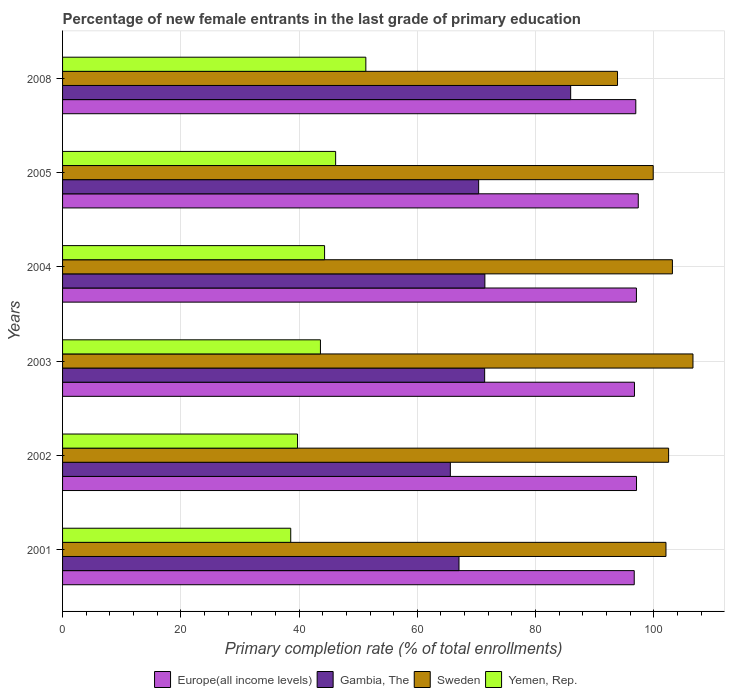How many groups of bars are there?
Your answer should be very brief. 6. How many bars are there on the 5th tick from the top?
Keep it short and to the point. 4. How many bars are there on the 2nd tick from the bottom?
Ensure brevity in your answer.  4. In how many cases, is the number of bars for a given year not equal to the number of legend labels?
Your answer should be compact. 0. What is the percentage of new female entrants in Gambia, The in 2001?
Your answer should be very brief. 67.05. Across all years, what is the maximum percentage of new female entrants in Europe(all income levels)?
Provide a short and direct response. 97.37. Across all years, what is the minimum percentage of new female entrants in Sweden?
Your response must be concise. 93.86. In which year was the percentage of new female entrants in Gambia, The maximum?
Your answer should be very brief. 2008. What is the total percentage of new female entrants in Yemen, Rep. in the graph?
Your answer should be compact. 263.76. What is the difference between the percentage of new female entrants in Sweden in 2004 and that in 2005?
Your response must be concise. 3.25. What is the difference between the percentage of new female entrants in Yemen, Rep. in 2008 and the percentage of new female entrants in Europe(all income levels) in 2003?
Ensure brevity in your answer.  -45.44. What is the average percentage of new female entrants in Europe(all income levels) per year?
Provide a succinct answer. 96.98. In the year 2005, what is the difference between the percentage of new female entrants in Sweden and percentage of new female entrants in Yemen, Rep.?
Provide a short and direct response. 53.71. In how many years, is the percentage of new female entrants in Gambia, The greater than 44 %?
Provide a succinct answer. 6. What is the ratio of the percentage of new female entrants in Gambia, The in 2001 to that in 2002?
Make the answer very short. 1.02. Is the percentage of new female entrants in Sweden in 2001 less than that in 2004?
Offer a very short reply. Yes. What is the difference between the highest and the second highest percentage of new female entrants in Gambia, The?
Keep it short and to the point. 14.51. What is the difference between the highest and the lowest percentage of new female entrants in Europe(all income levels)?
Ensure brevity in your answer.  0.68. What does the 4th bar from the top in 2004 represents?
Your answer should be very brief. Europe(all income levels). What does the 1st bar from the bottom in 2003 represents?
Your response must be concise. Europe(all income levels). What is the difference between two consecutive major ticks on the X-axis?
Offer a very short reply. 20. Are the values on the major ticks of X-axis written in scientific E-notation?
Keep it short and to the point. No. Does the graph contain grids?
Offer a very short reply. Yes. How many legend labels are there?
Ensure brevity in your answer.  4. How are the legend labels stacked?
Offer a very short reply. Horizontal. What is the title of the graph?
Your answer should be compact. Percentage of new female entrants in the last grade of primary education. What is the label or title of the X-axis?
Your response must be concise. Primary completion rate (% of total enrollments). What is the label or title of the Y-axis?
Offer a very short reply. Years. What is the Primary completion rate (% of total enrollments) in Europe(all income levels) in 2001?
Your answer should be very brief. 96.69. What is the Primary completion rate (% of total enrollments) of Gambia, The in 2001?
Your response must be concise. 67.05. What is the Primary completion rate (% of total enrollments) of Sweden in 2001?
Offer a terse response. 102.06. What is the Primary completion rate (% of total enrollments) in Yemen, Rep. in 2001?
Provide a succinct answer. 38.59. What is the Primary completion rate (% of total enrollments) in Europe(all income levels) in 2002?
Your answer should be very brief. 97.08. What is the Primary completion rate (% of total enrollments) in Gambia, The in 2002?
Your answer should be very brief. 65.59. What is the Primary completion rate (% of total enrollments) of Sweden in 2002?
Provide a succinct answer. 102.51. What is the Primary completion rate (% of total enrollments) in Yemen, Rep. in 2002?
Offer a very short reply. 39.74. What is the Primary completion rate (% of total enrollments) of Europe(all income levels) in 2003?
Provide a short and direct response. 96.73. What is the Primary completion rate (% of total enrollments) in Gambia, The in 2003?
Provide a short and direct response. 71.39. What is the Primary completion rate (% of total enrollments) in Sweden in 2003?
Ensure brevity in your answer.  106.63. What is the Primary completion rate (% of total enrollments) in Yemen, Rep. in 2003?
Provide a short and direct response. 43.62. What is the Primary completion rate (% of total enrollments) in Europe(all income levels) in 2004?
Give a very brief answer. 97.06. What is the Primary completion rate (% of total enrollments) in Gambia, The in 2004?
Offer a terse response. 71.43. What is the Primary completion rate (% of total enrollments) in Sweden in 2004?
Your answer should be compact. 103.15. What is the Primary completion rate (% of total enrollments) of Yemen, Rep. in 2004?
Your response must be concise. 44.32. What is the Primary completion rate (% of total enrollments) in Europe(all income levels) in 2005?
Provide a succinct answer. 97.37. What is the Primary completion rate (% of total enrollments) in Gambia, The in 2005?
Make the answer very short. 70.38. What is the Primary completion rate (% of total enrollments) of Sweden in 2005?
Provide a succinct answer. 99.9. What is the Primary completion rate (% of total enrollments) in Yemen, Rep. in 2005?
Your answer should be very brief. 46.19. What is the Primary completion rate (% of total enrollments) of Europe(all income levels) in 2008?
Ensure brevity in your answer.  96.96. What is the Primary completion rate (% of total enrollments) in Gambia, The in 2008?
Offer a very short reply. 85.94. What is the Primary completion rate (% of total enrollments) of Sweden in 2008?
Offer a very short reply. 93.86. What is the Primary completion rate (% of total enrollments) of Yemen, Rep. in 2008?
Keep it short and to the point. 51.3. Across all years, what is the maximum Primary completion rate (% of total enrollments) in Europe(all income levels)?
Ensure brevity in your answer.  97.37. Across all years, what is the maximum Primary completion rate (% of total enrollments) of Gambia, The?
Make the answer very short. 85.94. Across all years, what is the maximum Primary completion rate (% of total enrollments) in Sweden?
Your answer should be very brief. 106.63. Across all years, what is the maximum Primary completion rate (% of total enrollments) of Yemen, Rep.?
Your response must be concise. 51.3. Across all years, what is the minimum Primary completion rate (% of total enrollments) of Europe(all income levels)?
Provide a succinct answer. 96.69. Across all years, what is the minimum Primary completion rate (% of total enrollments) in Gambia, The?
Offer a terse response. 65.59. Across all years, what is the minimum Primary completion rate (% of total enrollments) of Sweden?
Offer a terse response. 93.86. Across all years, what is the minimum Primary completion rate (% of total enrollments) in Yemen, Rep.?
Ensure brevity in your answer.  38.59. What is the total Primary completion rate (% of total enrollments) in Europe(all income levels) in the graph?
Offer a terse response. 581.9. What is the total Primary completion rate (% of total enrollments) in Gambia, The in the graph?
Make the answer very short. 431.78. What is the total Primary completion rate (% of total enrollments) in Sweden in the graph?
Give a very brief answer. 608.11. What is the total Primary completion rate (% of total enrollments) in Yemen, Rep. in the graph?
Provide a short and direct response. 263.76. What is the difference between the Primary completion rate (% of total enrollments) in Europe(all income levels) in 2001 and that in 2002?
Provide a succinct answer. -0.39. What is the difference between the Primary completion rate (% of total enrollments) of Gambia, The in 2001 and that in 2002?
Your response must be concise. 1.46. What is the difference between the Primary completion rate (% of total enrollments) of Sweden in 2001 and that in 2002?
Your answer should be compact. -0.45. What is the difference between the Primary completion rate (% of total enrollments) in Yemen, Rep. in 2001 and that in 2002?
Your response must be concise. -1.15. What is the difference between the Primary completion rate (% of total enrollments) of Europe(all income levels) in 2001 and that in 2003?
Provide a short and direct response. -0.04. What is the difference between the Primary completion rate (% of total enrollments) in Gambia, The in 2001 and that in 2003?
Provide a short and direct response. -4.34. What is the difference between the Primary completion rate (% of total enrollments) of Sweden in 2001 and that in 2003?
Offer a terse response. -4.57. What is the difference between the Primary completion rate (% of total enrollments) of Yemen, Rep. in 2001 and that in 2003?
Your answer should be compact. -5.02. What is the difference between the Primary completion rate (% of total enrollments) of Europe(all income levels) in 2001 and that in 2004?
Your answer should be very brief. -0.37. What is the difference between the Primary completion rate (% of total enrollments) in Gambia, The in 2001 and that in 2004?
Your answer should be compact. -4.37. What is the difference between the Primary completion rate (% of total enrollments) in Sweden in 2001 and that in 2004?
Make the answer very short. -1.09. What is the difference between the Primary completion rate (% of total enrollments) of Yemen, Rep. in 2001 and that in 2004?
Offer a terse response. -5.73. What is the difference between the Primary completion rate (% of total enrollments) in Europe(all income levels) in 2001 and that in 2005?
Provide a succinct answer. -0.68. What is the difference between the Primary completion rate (% of total enrollments) of Gambia, The in 2001 and that in 2005?
Your response must be concise. -3.32. What is the difference between the Primary completion rate (% of total enrollments) of Sweden in 2001 and that in 2005?
Keep it short and to the point. 2.16. What is the difference between the Primary completion rate (% of total enrollments) of Yemen, Rep. in 2001 and that in 2005?
Give a very brief answer. -7.6. What is the difference between the Primary completion rate (% of total enrollments) in Europe(all income levels) in 2001 and that in 2008?
Your answer should be very brief. -0.26. What is the difference between the Primary completion rate (% of total enrollments) in Gambia, The in 2001 and that in 2008?
Your answer should be very brief. -18.89. What is the difference between the Primary completion rate (% of total enrollments) in Sweden in 2001 and that in 2008?
Give a very brief answer. 8.2. What is the difference between the Primary completion rate (% of total enrollments) in Yemen, Rep. in 2001 and that in 2008?
Your answer should be very brief. -12.7. What is the difference between the Primary completion rate (% of total enrollments) in Europe(all income levels) in 2002 and that in 2003?
Provide a succinct answer. 0.35. What is the difference between the Primary completion rate (% of total enrollments) in Gambia, The in 2002 and that in 2003?
Your answer should be compact. -5.8. What is the difference between the Primary completion rate (% of total enrollments) in Sweden in 2002 and that in 2003?
Keep it short and to the point. -4.12. What is the difference between the Primary completion rate (% of total enrollments) of Yemen, Rep. in 2002 and that in 2003?
Ensure brevity in your answer.  -3.87. What is the difference between the Primary completion rate (% of total enrollments) of Europe(all income levels) in 2002 and that in 2004?
Offer a very short reply. 0.02. What is the difference between the Primary completion rate (% of total enrollments) in Gambia, The in 2002 and that in 2004?
Offer a very short reply. -5.84. What is the difference between the Primary completion rate (% of total enrollments) of Sweden in 2002 and that in 2004?
Ensure brevity in your answer.  -0.64. What is the difference between the Primary completion rate (% of total enrollments) of Yemen, Rep. in 2002 and that in 2004?
Your answer should be very brief. -4.57. What is the difference between the Primary completion rate (% of total enrollments) in Europe(all income levels) in 2002 and that in 2005?
Keep it short and to the point. -0.29. What is the difference between the Primary completion rate (% of total enrollments) of Gambia, The in 2002 and that in 2005?
Make the answer very short. -4.79. What is the difference between the Primary completion rate (% of total enrollments) of Sweden in 2002 and that in 2005?
Your answer should be very brief. 2.6. What is the difference between the Primary completion rate (% of total enrollments) of Yemen, Rep. in 2002 and that in 2005?
Your answer should be compact. -6.45. What is the difference between the Primary completion rate (% of total enrollments) in Europe(all income levels) in 2002 and that in 2008?
Offer a very short reply. 0.12. What is the difference between the Primary completion rate (% of total enrollments) in Gambia, The in 2002 and that in 2008?
Your response must be concise. -20.35. What is the difference between the Primary completion rate (% of total enrollments) of Sweden in 2002 and that in 2008?
Keep it short and to the point. 8.64. What is the difference between the Primary completion rate (% of total enrollments) of Yemen, Rep. in 2002 and that in 2008?
Ensure brevity in your answer.  -11.55. What is the difference between the Primary completion rate (% of total enrollments) in Europe(all income levels) in 2003 and that in 2004?
Give a very brief answer. -0.33. What is the difference between the Primary completion rate (% of total enrollments) in Gambia, The in 2003 and that in 2004?
Provide a short and direct response. -0.04. What is the difference between the Primary completion rate (% of total enrollments) of Sweden in 2003 and that in 2004?
Your answer should be very brief. 3.48. What is the difference between the Primary completion rate (% of total enrollments) in Yemen, Rep. in 2003 and that in 2004?
Make the answer very short. -0.7. What is the difference between the Primary completion rate (% of total enrollments) in Europe(all income levels) in 2003 and that in 2005?
Ensure brevity in your answer.  -0.64. What is the difference between the Primary completion rate (% of total enrollments) of Gambia, The in 2003 and that in 2005?
Your response must be concise. 1.01. What is the difference between the Primary completion rate (% of total enrollments) in Sweden in 2003 and that in 2005?
Offer a terse response. 6.73. What is the difference between the Primary completion rate (% of total enrollments) of Yemen, Rep. in 2003 and that in 2005?
Keep it short and to the point. -2.57. What is the difference between the Primary completion rate (% of total enrollments) in Europe(all income levels) in 2003 and that in 2008?
Provide a short and direct response. -0.22. What is the difference between the Primary completion rate (% of total enrollments) in Gambia, The in 2003 and that in 2008?
Your answer should be very brief. -14.55. What is the difference between the Primary completion rate (% of total enrollments) in Sweden in 2003 and that in 2008?
Your answer should be compact. 12.76. What is the difference between the Primary completion rate (% of total enrollments) of Yemen, Rep. in 2003 and that in 2008?
Your answer should be very brief. -7.68. What is the difference between the Primary completion rate (% of total enrollments) of Europe(all income levels) in 2004 and that in 2005?
Provide a succinct answer. -0.31. What is the difference between the Primary completion rate (% of total enrollments) in Gambia, The in 2004 and that in 2005?
Ensure brevity in your answer.  1.05. What is the difference between the Primary completion rate (% of total enrollments) of Sweden in 2004 and that in 2005?
Make the answer very short. 3.25. What is the difference between the Primary completion rate (% of total enrollments) in Yemen, Rep. in 2004 and that in 2005?
Provide a short and direct response. -1.87. What is the difference between the Primary completion rate (% of total enrollments) in Europe(all income levels) in 2004 and that in 2008?
Offer a very short reply. 0.11. What is the difference between the Primary completion rate (% of total enrollments) of Gambia, The in 2004 and that in 2008?
Give a very brief answer. -14.51. What is the difference between the Primary completion rate (% of total enrollments) of Sweden in 2004 and that in 2008?
Your response must be concise. 9.29. What is the difference between the Primary completion rate (% of total enrollments) in Yemen, Rep. in 2004 and that in 2008?
Make the answer very short. -6.98. What is the difference between the Primary completion rate (% of total enrollments) of Europe(all income levels) in 2005 and that in 2008?
Offer a very short reply. 0.42. What is the difference between the Primary completion rate (% of total enrollments) of Gambia, The in 2005 and that in 2008?
Keep it short and to the point. -15.57. What is the difference between the Primary completion rate (% of total enrollments) in Sweden in 2005 and that in 2008?
Give a very brief answer. 6.04. What is the difference between the Primary completion rate (% of total enrollments) of Yemen, Rep. in 2005 and that in 2008?
Give a very brief answer. -5.11. What is the difference between the Primary completion rate (% of total enrollments) in Europe(all income levels) in 2001 and the Primary completion rate (% of total enrollments) in Gambia, The in 2002?
Keep it short and to the point. 31.1. What is the difference between the Primary completion rate (% of total enrollments) in Europe(all income levels) in 2001 and the Primary completion rate (% of total enrollments) in Sweden in 2002?
Keep it short and to the point. -5.81. What is the difference between the Primary completion rate (% of total enrollments) in Europe(all income levels) in 2001 and the Primary completion rate (% of total enrollments) in Yemen, Rep. in 2002?
Your response must be concise. 56.95. What is the difference between the Primary completion rate (% of total enrollments) in Gambia, The in 2001 and the Primary completion rate (% of total enrollments) in Sweden in 2002?
Provide a short and direct response. -35.45. What is the difference between the Primary completion rate (% of total enrollments) of Gambia, The in 2001 and the Primary completion rate (% of total enrollments) of Yemen, Rep. in 2002?
Provide a succinct answer. 27.31. What is the difference between the Primary completion rate (% of total enrollments) in Sweden in 2001 and the Primary completion rate (% of total enrollments) in Yemen, Rep. in 2002?
Make the answer very short. 62.31. What is the difference between the Primary completion rate (% of total enrollments) in Europe(all income levels) in 2001 and the Primary completion rate (% of total enrollments) in Gambia, The in 2003?
Offer a terse response. 25.3. What is the difference between the Primary completion rate (% of total enrollments) of Europe(all income levels) in 2001 and the Primary completion rate (% of total enrollments) of Sweden in 2003?
Ensure brevity in your answer.  -9.93. What is the difference between the Primary completion rate (% of total enrollments) of Europe(all income levels) in 2001 and the Primary completion rate (% of total enrollments) of Yemen, Rep. in 2003?
Make the answer very short. 53.08. What is the difference between the Primary completion rate (% of total enrollments) in Gambia, The in 2001 and the Primary completion rate (% of total enrollments) in Sweden in 2003?
Keep it short and to the point. -39.57. What is the difference between the Primary completion rate (% of total enrollments) in Gambia, The in 2001 and the Primary completion rate (% of total enrollments) in Yemen, Rep. in 2003?
Your answer should be very brief. 23.44. What is the difference between the Primary completion rate (% of total enrollments) in Sweden in 2001 and the Primary completion rate (% of total enrollments) in Yemen, Rep. in 2003?
Offer a very short reply. 58.44. What is the difference between the Primary completion rate (% of total enrollments) in Europe(all income levels) in 2001 and the Primary completion rate (% of total enrollments) in Gambia, The in 2004?
Offer a terse response. 25.26. What is the difference between the Primary completion rate (% of total enrollments) of Europe(all income levels) in 2001 and the Primary completion rate (% of total enrollments) of Sweden in 2004?
Your response must be concise. -6.46. What is the difference between the Primary completion rate (% of total enrollments) of Europe(all income levels) in 2001 and the Primary completion rate (% of total enrollments) of Yemen, Rep. in 2004?
Provide a short and direct response. 52.38. What is the difference between the Primary completion rate (% of total enrollments) of Gambia, The in 2001 and the Primary completion rate (% of total enrollments) of Sweden in 2004?
Provide a short and direct response. -36.09. What is the difference between the Primary completion rate (% of total enrollments) in Gambia, The in 2001 and the Primary completion rate (% of total enrollments) in Yemen, Rep. in 2004?
Your answer should be compact. 22.74. What is the difference between the Primary completion rate (% of total enrollments) of Sweden in 2001 and the Primary completion rate (% of total enrollments) of Yemen, Rep. in 2004?
Make the answer very short. 57.74. What is the difference between the Primary completion rate (% of total enrollments) of Europe(all income levels) in 2001 and the Primary completion rate (% of total enrollments) of Gambia, The in 2005?
Ensure brevity in your answer.  26.32. What is the difference between the Primary completion rate (% of total enrollments) of Europe(all income levels) in 2001 and the Primary completion rate (% of total enrollments) of Sweden in 2005?
Your answer should be very brief. -3.21. What is the difference between the Primary completion rate (% of total enrollments) in Europe(all income levels) in 2001 and the Primary completion rate (% of total enrollments) in Yemen, Rep. in 2005?
Your answer should be compact. 50.5. What is the difference between the Primary completion rate (% of total enrollments) in Gambia, The in 2001 and the Primary completion rate (% of total enrollments) in Sweden in 2005?
Offer a terse response. -32.85. What is the difference between the Primary completion rate (% of total enrollments) in Gambia, The in 2001 and the Primary completion rate (% of total enrollments) in Yemen, Rep. in 2005?
Provide a short and direct response. 20.87. What is the difference between the Primary completion rate (% of total enrollments) of Sweden in 2001 and the Primary completion rate (% of total enrollments) of Yemen, Rep. in 2005?
Provide a short and direct response. 55.87. What is the difference between the Primary completion rate (% of total enrollments) in Europe(all income levels) in 2001 and the Primary completion rate (% of total enrollments) in Gambia, The in 2008?
Give a very brief answer. 10.75. What is the difference between the Primary completion rate (% of total enrollments) in Europe(all income levels) in 2001 and the Primary completion rate (% of total enrollments) in Sweden in 2008?
Ensure brevity in your answer.  2.83. What is the difference between the Primary completion rate (% of total enrollments) of Europe(all income levels) in 2001 and the Primary completion rate (% of total enrollments) of Yemen, Rep. in 2008?
Give a very brief answer. 45.4. What is the difference between the Primary completion rate (% of total enrollments) in Gambia, The in 2001 and the Primary completion rate (% of total enrollments) in Sweden in 2008?
Make the answer very short. -26.81. What is the difference between the Primary completion rate (% of total enrollments) of Gambia, The in 2001 and the Primary completion rate (% of total enrollments) of Yemen, Rep. in 2008?
Keep it short and to the point. 15.76. What is the difference between the Primary completion rate (% of total enrollments) of Sweden in 2001 and the Primary completion rate (% of total enrollments) of Yemen, Rep. in 2008?
Offer a terse response. 50.76. What is the difference between the Primary completion rate (% of total enrollments) of Europe(all income levels) in 2002 and the Primary completion rate (% of total enrollments) of Gambia, The in 2003?
Give a very brief answer. 25.69. What is the difference between the Primary completion rate (% of total enrollments) of Europe(all income levels) in 2002 and the Primary completion rate (% of total enrollments) of Sweden in 2003?
Your response must be concise. -9.55. What is the difference between the Primary completion rate (% of total enrollments) of Europe(all income levels) in 2002 and the Primary completion rate (% of total enrollments) of Yemen, Rep. in 2003?
Your answer should be very brief. 53.46. What is the difference between the Primary completion rate (% of total enrollments) of Gambia, The in 2002 and the Primary completion rate (% of total enrollments) of Sweden in 2003?
Offer a terse response. -41.04. What is the difference between the Primary completion rate (% of total enrollments) of Gambia, The in 2002 and the Primary completion rate (% of total enrollments) of Yemen, Rep. in 2003?
Your response must be concise. 21.97. What is the difference between the Primary completion rate (% of total enrollments) in Sweden in 2002 and the Primary completion rate (% of total enrollments) in Yemen, Rep. in 2003?
Give a very brief answer. 58.89. What is the difference between the Primary completion rate (% of total enrollments) in Europe(all income levels) in 2002 and the Primary completion rate (% of total enrollments) in Gambia, The in 2004?
Your answer should be very brief. 25.65. What is the difference between the Primary completion rate (% of total enrollments) in Europe(all income levels) in 2002 and the Primary completion rate (% of total enrollments) in Sweden in 2004?
Make the answer very short. -6.07. What is the difference between the Primary completion rate (% of total enrollments) in Europe(all income levels) in 2002 and the Primary completion rate (% of total enrollments) in Yemen, Rep. in 2004?
Offer a terse response. 52.76. What is the difference between the Primary completion rate (% of total enrollments) in Gambia, The in 2002 and the Primary completion rate (% of total enrollments) in Sweden in 2004?
Your answer should be very brief. -37.56. What is the difference between the Primary completion rate (% of total enrollments) of Gambia, The in 2002 and the Primary completion rate (% of total enrollments) of Yemen, Rep. in 2004?
Provide a succinct answer. 21.27. What is the difference between the Primary completion rate (% of total enrollments) of Sweden in 2002 and the Primary completion rate (% of total enrollments) of Yemen, Rep. in 2004?
Keep it short and to the point. 58.19. What is the difference between the Primary completion rate (% of total enrollments) of Europe(all income levels) in 2002 and the Primary completion rate (% of total enrollments) of Gambia, The in 2005?
Offer a very short reply. 26.7. What is the difference between the Primary completion rate (% of total enrollments) in Europe(all income levels) in 2002 and the Primary completion rate (% of total enrollments) in Sweden in 2005?
Provide a succinct answer. -2.82. What is the difference between the Primary completion rate (% of total enrollments) of Europe(all income levels) in 2002 and the Primary completion rate (% of total enrollments) of Yemen, Rep. in 2005?
Make the answer very short. 50.89. What is the difference between the Primary completion rate (% of total enrollments) in Gambia, The in 2002 and the Primary completion rate (% of total enrollments) in Sweden in 2005?
Your answer should be compact. -34.31. What is the difference between the Primary completion rate (% of total enrollments) of Gambia, The in 2002 and the Primary completion rate (% of total enrollments) of Yemen, Rep. in 2005?
Offer a very short reply. 19.4. What is the difference between the Primary completion rate (% of total enrollments) of Sweden in 2002 and the Primary completion rate (% of total enrollments) of Yemen, Rep. in 2005?
Give a very brief answer. 56.32. What is the difference between the Primary completion rate (% of total enrollments) in Europe(all income levels) in 2002 and the Primary completion rate (% of total enrollments) in Gambia, The in 2008?
Offer a very short reply. 11.14. What is the difference between the Primary completion rate (% of total enrollments) of Europe(all income levels) in 2002 and the Primary completion rate (% of total enrollments) of Sweden in 2008?
Your answer should be compact. 3.22. What is the difference between the Primary completion rate (% of total enrollments) of Europe(all income levels) in 2002 and the Primary completion rate (% of total enrollments) of Yemen, Rep. in 2008?
Give a very brief answer. 45.78. What is the difference between the Primary completion rate (% of total enrollments) of Gambia, The in 2002 and the Primary completion rate (% of total enrollments) of Sweden in 2008?
Provide a succinct answer. -28.27. What is the difference between the Primary completion rate (% of total enrollments) in Gambia, The in 2002 and the Primary completion rate (% of total enrollments) in Yemen, Rep. in 2008?
Make the answer very short. 14.29. What is the difference between the Primary completion rate (% of total enrollments) of Sweden in 2002 and the Primary completion rate (% of total enrollments) of Yemen, Rep. in 2008?
Make the answer very short. 51.21. What is the difference between the Primary completion rate (% of total enrollments) in Europe(all income levels) in 2003 and the Primary completion rate (% of total enrollments) in Gambia, The in 2004?
Your response must be concise. 25.3. What is the difference between the Primary completion rate (% of total enrollments) of Europe(all income levels) in 2003 and the Primary completion rate (% of total enrollments) of Sweden in 2004?
Your answer should be very brief. -6.42. What is the difference between the Primary completion rate (% of total enrollments) in Europe(all income levels) in 2003 and the Primary completion rate (% of total enrollments) in Yemen, Rep. in 2004?
Provide a succinct answer. 52.41. What is the difference between the Primary completion rate (% of total enrollments) in Gambia, The in 2003 and the Primary completion rate (% of total enrollments) in Sweden in 2004?
Give a very brief answer. -31.76. What is the difference between the Primary completion rate (% of total enrollments) of Gambia, The in 2003 and the Primary completion rate (% of total enrollments) of Yemen, Rep. in 2004?
Provide a succinct answer. 27.07. What is the difference between the Primary completion rate (% of total enrollments) in Sweden in 2003 and the Primary completion rate (% of total enrollments) in Yemen, Rep. in 2004?
Ensure brevity in your answer.  62.31. What is the difference between the Primary completion rate (% of total enrollments) in Europe(all income levels) in 2003 and the Primary completion rate (% of total enrollments) in Gambia, The in 2005?
Keep it short and to the point. 26.36. What is the difference between the Primary completion rate (% of total enrollments) in Europe(all income levels) in 2003 and the Primary completion rate (% of total enrollments) in Sweden in 2005?
Offer a terse response. -3.17. What is the difference between the Primary completion rate (% of total enrollments) of Europe(all income levels) in 2003 and the Primary completion rate (% of total enrollments) of Yemen, Rep. in 2005?
Give a very brief answer. 50.54. What is the difference between the Primary completion rate (% of total enrollments) in Gambia, The in 2003 and the Primary completion rate (% of total enrollments) in Sweden in 2005?
Provide a succinct answer. -28.51. What is the difference between the Primary completion rate (% of total enrollments) in Gambia, The in 2003 and the Primary completion rate (% of total enrollments) in Yemen, Rep. in 2005?
Your answer should be very brief. 25.2. What is the difference between the Primary completion rate (% of total enrollments) in Sweden in 2003 and the Primary completion rate (% of total enrollments) in Yemen, Rep. in 2005?
Your response must be concise. 60.44. What is the difference between the Primary completion rate (% of total enrollments) of Europe(all income levels) in 2003 and the Primary completion rate (% of total enrollments) of Gambia, The in 2008?
Offer a terse response. 10.79. What is the difference between the Primary completion rate (% of total enrollments) of Europe(all income levels) in 2003 and the Primary completion rate (% of total enrollments) of Sweden in 2008?
Offer a very short reply. 2.87. What is the difference between the Primary completion rate (% of total enrollments) of Europe(all income levels) in 2003 and the Primary completion rate (% of total enrollments) of Yemen, Rep. in 2008?
Keep it short and to the point. 45.44. What is the difference between the Primary completion rate (% of total enrollments) of Gambia, The in 2003 and the Primary completion rate (% of total enrollments) of Sweden in 2008?
Keep it short and to the point. -22.47. What is the difference between the Primary completion rate (% of total enrollments) of Gambia, The in 2003 and the Primary completion rate (% of total enrollments) of Yemen, Rep. in 2008?
Provide a short and direct response. 20.1. What is the difference between the Primary completion rate (% of total enrollments) in Sweden in 2003 and the Primary completion rate (% of total enrollments) in Yemen, Rep. in 2008?
Ensure brevity in your answer.  55.33. What is the difference between the Primary completion rate (% of total enrollments) of Europe(all income levels) in 2004 and the Primary completion rate (% of total enrollments) of Gambia, The in 2005?
Give a very brief answer. 26.68. What is the difference between the Primary completion rate (% of total enrollments) in Europe(all income levels) in 2004 and the Primary completion rate (% of total enrollments) in Sweden in 2005?
Your answer should be very brief. -2.84. What is the difference between the Primary completion rate (% of total enrollments) of Europe(all income levels) in 2004 and the Primary completion rate (% of total enrollments) of Yemen, Rep. in 2005?
Offer a very short reply. 50.87. What is the difference between the Primary completion rate (% of total enrollments) of Gambia, The in 2004 and the Primary completion rate (% of total enrollments) of Sweden in 2005?
Ensure brevity in your answer.  -28.47. What is the difference between the Primary completion rate (% of total enrollments) in Gambia, The in 2004 and the Primary completion rate (% of total enrollments) in Yemen, Rep. in 2005?
Keep it short and to the point. 25.24. What is the difference between the Primary completion rate (% of total enrollments) in Sweden in 2004 and the Primary completion rate (% of total enrollments) in Yemen, Rep. in 2005?
Your answer should be compact. 56.96. What is the difference between the Primary completion rate (% of total enrollments) in Europe(all income levels) in 2004 and the Primary completion rate (% of total enrollments) in Gambia, The in 2008?
Give a very brief answer. 11.12. What is the difference between the Primary completion rate (% of total enrollments) in Europe(all income levels) in 2004 and the Primary completion rate (% of total enrollments) in Sweden in 2008?
Your response must be concise. 3.2. What is the difference between the Primary completion rate (% of total enrollments) in Europe(all income levels) in 2004 and the Primary completion rate (% of total enrollments) in Yemen, Rep. in 2008?
Your response must be concise. 45.77. What is the difference between the Primary completion rate (% of total enrollments) in Gambia, The in 2004 and the Primary completion rate (% of total enrollments) in Sweden in 2008?
Keep it short and to the point. -22.43. What is the difference between the Primary completion rate (% of total enrollments) of Gambia, The in 2004 and the Primary completion rate (% of total enrollments) of Yemen, Rep. in 2008?
Provide a succinct answer. 20.13. What is the difference between the Primary completion rate (% of total enrollments) of Sweden in 2004 and the Primary completion rate (% of total enrollments) of Yemen, Rep. in 2008?
Provide a short and direct response. 51.85. What is the difference between the Primary completion rate (% of total enrollments) in Europe(all income levels) in 2005 and the Primary completion rate (% of total enrollments) in Gambia, The in 2008?
Ensure brevity in your answer.  11.43. What is the difference between the Primary completion rate (% of total enrollments) in Europe(all income levels) in 2005 and the Primary completion rate (% of total enrollments) in Sweden in 2008?
Ensure brevity in your answer.  3.51. What is the difference between the Primary completion rate (% of total enrollments) in Europe(all income levels) in 2005 and the Primary completion rate (% of total enrollments) in Yemen, Rep. in 2008?
Give a very brief answer. 46.08. What is the difference between the Primary completion rate (% of total enrollments) in Gambia, The in 2005 and the Primary completion rate (% of total enrollments) in Sweden in 2008?
Provide a succinct answer. -23.49. What is the difference between the Primary completion rate (% of total enrollments) of Gambia, The in 2005 and the Primary completion rate (% of total enrollments) of Yemen, Rep. in 2008?
Keep it short and to the point. 19.08. What is the difference between the Primary completion rate (% of total enrollments) of Sweden in 2005 and the Primary completion rate (% of total enrollments) of Yemen, Rep. in 2008?
Keep it short and to the point. 48.61. What is the average Primary completion rate (% of total enrollments) of Europe(all income levels) per year?
Provide a succinct answer. 96.98. What is the average Primary completion rate (% of total enrollments) in Gambia, The per year?
Your answer should be compact. 71.96. What is the average Primary completion rate (% of total enrollments) in Sweden per year?
Your answer should be compact. 101.35. What is the average Primary completion rate (% of total enrollments) in Yemen, Rep. per year?
Your answer should be compact. 43.96. In the year 2001, what is the difference between the Primary completion rate (% of total enrollments) in Europe(all income levels) and Primary completion rate (% of total enrollments) in Gambia, The?
Your response must be concise. 29.64. In the year 2001, what is the difference between the Primary completion rate (% of total enrollments) of Europe(all income levels) and Primary completion rate (% of total enrollments) of Sweden?
Your answer should be very brief. -5.37. In the year 2001, what is the difference between the Primary completion rate (% of total enrollments) of Europe(all income levels) and Primary completion rate (% of total enrollments) of Yemen, Rep.?
Offer a very short reply. 58.1. In the year 2001, what is the difference between the Primary completion rate (% of total enrollments) of Gambia, The and Primary completion rate (% of total enrollments) of Sweden?
Provide a short and direct response. -35. In the year 2001, what is the difference between the Primary completion rate (% of total enrollments) in Gambia, The and Primary completion rate (% of total enrollments) in Yemen, Rep.?
Give a very brief answer. 28.46. In the year 2001, what is the difference between the Primary completion rate (% of total enrollments) in Sweden and Primary completion rate (% of total enrollments) in Yemen, Rep.?
Provide a short and direct response. 63.47. In the year 2002, what is the difference between the Primary completion rate (% of total enrollments) of Europe(all income levels) and Primary completion rate (% of total enrollments) of Gambia, The?
Offer a very short reply. 31.49. In the year 2002, what is the difference between the Primary completion rate (% of total enrollments) in Europe(all income levels) and Primary completion rate (% of total enrollments) in Sweden?
Offer a very short reply. -5.43. In the year 2002, what is the difference between the Primary completion rate (% of total enrollments) of Europe(all income levels) and Primary completion rate (% of total enrollments) of Yemen, Rep.?
Offer a very short reply. 57.34. In the year 2002, what is the difference between the Primary completion rate (% of total enrollments) of Gambia, The and Primary completion rate (% of total enrollments) of Sweden?
Your answer should be very brief. -36.92. In the year 2002, what is the difference between the Primary completion rate (% of total enrollments) of Gambia, The and Primary completion rate (% of total enrollments) of Yemen, Rep.?
Ensure brevity in your answer.  25.85. In the year 2002, what is the difference between the Primary completion rate (% of total enrollments) of Sweden and Primary completion rate (% of total enrollments) of Yemen, Rep.?
Your answer should be compact. 62.76. In the year 2003, what is the difference between the Primary completion rate (% of total enrollments) of Europe(all income levels) and Primary completion rate (% of total enrollments) of Gambia, The?
Your response must be concise. 25.34. In the year 2003, what is the difference between the Primary completion rate (% of total enrollments) of Europe(all income levels) and Primary completion rate (% of total enrollments) of Sweden?
Provide a short and direct response. -9.89. In the year 2003, what is the difference between the Primary completion rate (% of total enrollments) in Europe(all income levels) and Primary completion rate (% of total enrollments) in Yemen, Rep.?
Your answer should be compact. 53.12. In the year 2003, what is the difference between the Primary completion rate (% of total enrollments) in Gambia, The and Primary completion rate (% of total enrollments) in Sweden?
Ensure brevity in your answer.  -35.24. In the year 2003, what is the difference between the Primary completion rate (% of total enrollments) in Gambia, The and Primary completion rate (% of total enrollments) in Yemen, Rep.?
Ensure brevity in your answer.  27.78. In the year 2003, what is the difference between the Primary completion rate (% of total enrollments) in Sweden and Primary completion rate (% of total enrollments) in Yemen, Rep.?
Your answer should be very brief. 63.01. In the year 2004, what is the difference between the Primary completion rate (% of total enrollments) of Europe(all income levels) and Primary completion rate (% of total enrollments) of Gambia, The?
Your answer should be very brief. 25.63. In the year 2004, what is the difference between the Primary completion rate (% of total enrollments) in Europe(all income levels) and Primary completion rate (% of total enrollments) in Sweden?
Your response must be concise. -6.09. In the year 2004, what is the difference between the Primary completion rate (% of total enrollments) of Europe(all income levels) and Primary completion rate (% of total enrollments) of Yemen, Rep.?
Make the answer very short. 52.74. In the year 2004, what is the difference between the Primary completion rate (% of total enrollments) of Gambia, The and Primary completion rate (% of total enrollments) of Sweden?
Offer a terse response. -31.72. In the year 2004, what is the difference between the Primary completion rate (% of total enrollments) in Gambia, The and Primary completion rate (% of total enrollments) in Yemen, Rep.?
Your answer should be very brief. 27.11. In the year 2004, what is the difference between the Primary completion rate (% of total enrollments) in Sweden and Primary completion rate (% of total enrollments) in Yemen, Rep.?
Your answer should be very brief. 58.83. In the year 2005, what is the difference between the Primary completion rate (% of total enrollments) in Europe(all income levels) and Primary completion rate (% of total enrollments) in Gambia, The?
Offer a terse response. 27. In the year 2005, what is the difference between the Primary completion rate (% of total enrollments) in Europe(all income levels) and Primary completion rate (% of total enrollments) in Sweden?
Your answer should be compact. -2.53. In the year 2005, what is the difference between the Primary completion rate (% of total enrollments) of Europe(all income levels) and Primary completion rate (% of total enrollments) of Yemen, Rep.?
Give a very brief answer. 51.18. In the year 2005, what is the difference between the Primary completion rate (% of total enrollments) in Gambia, The and Primary completion rate (% of total enrollments) in Sweden?
Provide a short and direct response. -29.52. In the year 2005, what is the difference between the Primary completion rate (% of total enrollments) of Gambia, The and Primary completion rate (% of total enrollments) of Yemen, Rep.?
Ensure brevity in your answer.  24.19. In the year 2005, what is the difference between the Primary completion rate (% of total enrollments) in Sweden and Primary completion rate (% of total enrollments) in Yemen, Rep.?
Your response must be concise. 53.71. In the year 2008, what is the difference between the Primary completion rate (% of total enrollments) in Europe(all income levels) and Primary completion rate (% of total enrollments) in Gambia, The?
Make the answer very short. 11.01. In the year 2008, what is the difference between the Primary completion rate (% of total enrollments) in Europe(all income levels) and Primary completion rate (% of total enrollments) in Sweden?
Your answer should be very brief. 3.09. In the year 2008, what is the difference between the Primary completion rate (% of total enrollments) of Europe(all income levels) and Primary completion rate (% of total enrollments) of Yemen, Rep.?
Your answer should be compact. 45.66. In the year 2008, what is the difference between the Primary completion rate (% of total enrollments) in Gambia, The and Primary completion rate (% of total enrollments) in Sweden?
Make the answer very short. -7.92. In the year 2008, what is the difference between the Primary completion rate (% of total enrollments) of Gambia, The and Primary completion rate (% of total enrollments) of Yemen, Rep.?
Provide a short and direct response. 34.65. In the year 2008, what is the difference between the Primary completion rate (% of total enrollments) of Sweden and Primary completion rate (% of total enrollments) of Yemen, Rep.?
Provide a succinct answer. 42.57. What is the ratio of the Primary completion rate (% of total enrollments) of Europe(all income levels) in 2001 to that in 2002?
Give a very brief answer. 1. What is the ratio of the Primary completion rate (% of total enrollments) in Gambia, The in 2001 to that in 2002?
Your answer should be very brief. 1.02. What is the ratio of the Primary completion rate (% of total enrollments) in Europe(all income levels) in 2001 to that in 2003?
Keep it short and to the point. 1. What is the ratio of the Primary completion rate (% of total enrollments) of Gambia, The in 2001 to that in 2003?
Ensure brevity in your answer.  0.94. What is the ratio of the Primary completion rate (% of total enrollments) of Sweden in 2001 to that in 2003?
Your response must be concise. 0.96. What is the ratio of the Primary completion rate (% of total enrollments) of Yemen, Rep. in 2001 to that in 2003?
Ensure brevity in your answer.  0.88. What is the ratio of the Primary completion rate (% of total enrollments) of Europe(all income levels) in 2001 to that in 2004?
Your answer should be compact. 1. What is the ratio of the Primary completion rate (% of total enrollments) in Gambia, The in 2001 to that in 2004?
Your response must be concise. 0.94. What is the ratio of the Primary completion rate (% of total enrollments) in Sweden in 2001 to that in 2004?
Your answer should be compact. 0.99. What is the ratio of the Primary completion rate (% of total enrollments) in Yemen, Rep. in 2001 to that in 2004?
Keep it short and to the point. 0.87. What is the ratio of the Primary completion rate (% of total enrollments) of Europe(all income levels) in 2001 to that in 2005?
Ensure brevity in your answer.  0.99. What is the ratio of the Primary completion rate (% of total enrollments) in Gambia, The in 2001 to that in 2005?
Ensure brevity in your answer.  0.95. What is the ratio of the Primary completion rate (% of total enrollments) of Sweden in 2001 to that in 2005?
Offer a terse response. 1.02. What is the ratio of the Primary completion rate (% of total enrollments) of Yemen, Rep. in 2001 to that in 2005?
Offer a terse response. 0.84. What is the ratio of the Primary completion rate (% of total enrollments) of Gambia, The in 2001 to that in 2008?
Offer a very short reply. 0.78. What is the ratio of the Primary completion rate (% of total enrollments) in Sweden in 2001 to that in 2008?
Your answer should be very brief. 1.09. What is the ratio of the Primary completion rate (% of total enrollments) of Yemen, Rep. in 2001 to that in 2008?
Your answer should be compact. 0.75. What is the ratio of the Primary completion rate (% of total enrollments) of Europe(all income levels) in 2002 to that in 2003?
Keep it short and to the point. 1. What is the ratio of the Primary completion rate (% of total enrollments) in Gambia, The in 2002 to that in 2003?
Your answer should be very brief. 0.92. What is the ratio of the Primary completion rate (% of total enrollments) in Sweden in 2002 to that in 2003?
Give a very brief answer. 0.96. What is the ratio of the Primary completion rate (% of total enrollments) in Yemen, Rep. in 2002 to that in 2003?
Provide a short and direct response. 0.91. What is the ratio of the Primary completion rate (% of total enrollments) in Europe(all income levels) in 2002 to that in 2004?
Provide a succinct answer. 1. What is the ratio of the Primary completion rate (% of total enrollments) of Gambia, The in 2002 to that in 2004?
Provide a short and direct response. 0.92. What is the ratio of the Primary completion rate (% of total enrollments) in Yemen, Rep. in 2002 to that in 2004?
Provide a short and direct response. 0.9. What is the ratio of the Primary completion rate (% of total enrollments) of Gambia, The in 2002 to that in 2005?
Provide a short and direct response. 0.93. What is the ratio of the Primary completion rate (% of total enrollments) of Sweden in 2002 to that in 2005?
Give a very brief answer. 1.03. What is the ratio of the Primary completion rate (% of total enrollments) of Yemen, Rep. in 2002 to that in 2005?
Offer a very short reply. 0.86. What is the ratio of the Primary completion rate (% of total enrollments) in Europe(all income levels) in 2002 to that in 2008?
Offer a terse response. 1. What is the ratio of the Primary completion rate (% of total enrollments) of Gambia, The in 2002 to that in 2008?
Your response must be concise. 0.76. What is the ratio of the Primary completion rate (% of total enrollments) in Sweden in 2002 to that in 2008?
Your answer should be compact. 1.09. What is the ratio of the Primary completion rate (% of total enrollments) of Yemen, Rep. in 2002 to that in 2008?
Give a very brief answer. 0.77. What is the ratio of the Primary completion rate (% of total enrollments) of Sweden in 2003 to that in 2004?
Keep it short and to the point. 1.03. What is the ratio of the Primary completion rate (% of total enrollments) in Yemen, Rep. in 2003 to that in 2004?
Your answer should be compact. 0.98. What is the ratio of the Primary completion rate (% of total enrollments) in Europe(all income levels) in 2003 to that in 2005?
Give a very brief answer. 0.99. What is the ratio of the Primary completion rate (% of total enrollments) of Gambia, The in 2003 to that in 2005?
Your response must be concise. 1.01. What is the ratio of the Primary completion rate (% of total enrollments) of Sweden in 2003 to that in 2005?
Give a very brief answer. 1.07. What is the ratio of the Primary completion rate (% of total enrollments) of Yemen, Rep. in 2003 to that in 2005?
Offer a terse response. 0.94. What is the ratio of the Primary completion rate (% of total enrollments) of Gambia, The in 2003 to that in 2008?
Provide a succinct answer. 0.83. What is the ratio of the Primary completion rate (% of total enrollments) in Sweden in 2003 to that in 2008?
Ensure brevity in your answer.  1.14. What is the ratio of the Primary completion rate (% of total enrollments) in Yemen, Rep. in 2003 to that in 2008?
Make the answer very short. 0.85. What is the ratio of the Primary completion rate (% of total enrollments) in Europe(all income levels) in 2004 to that in 2005?
Ensure brevity in your answer.  1. What is the ratio of the Primary completion rate (% of total enrollments) in Gambia, The in 2004 to that in 2005?
Offer a terse response. 1.01. What is the ratio of the Primary completion rate (% of total enrollments) in Sweden in 2004 to that in 2005?
Offer a very short reply. 1.03. What is the ratio of the Primary completion rate (% of total enrollments) of Yemen, Rep. in 2004 to that in 2005?
Ensure brevity in your answer.  0.96. What is the ratio of the Primary completion rate (% of total enrollments) of Europe(all income levels) in 2004 to that in 2008?
Your answer should be very brief. 1. What is the ratio of the Primary completion rate (% of total enrollments) in Gambia, The in 2004 to that in 2008?
Your response must be concise. 0.83. What is the ratio of the Primary completion rate (% of total enrollments) of Sweden in 2004 to that in 2008?
Offer a terse response. 1.1. What is the ratio of the Primary completion rate (% of total enrollments) of Yemen, Rep. in 2004 to that in 2008?
Keep it short and to the point. 0.86. What is the ratio of the Primary completion rate (% of total enrollments) of Europe(all income levels) in 2005 to that in 2008?
Provide a succinct answer. 1. What is the ratio of the Primary completion rate (% of total enrollments) in Gambia, The in 2005 to that in 2008?
Give a very brief answer. 0.82. What is the ratio of the Primary completion rate (% of total enrollments) of Sweden in 2005 to that in 2008?
Make the answer very short. 1.06. What is the ratio of the Primary completion rate (% of total enrollments) in Yemen, Rep. in 2005 to that in 2008?
Make the answer very short. 0.9. What is the difference between the highest and the second highest Primary completion rate (% of total enrollments) of Europe(all income levels)?
Provide a short and direct response. 0.29. What is the difference between the highest and the second highest Primary completion rate (% of total enrollments) in Gambia, The?
Your answer should be very brief. 14.51. What is the difference between the highest and the second highest Primary completion rate (% of total enrollments) in Sweden?
Offer a very short reply. 3.48. What is the difference between the highest and the second highest Primary completion rate (% of total enrollments) in Yemen, Rep.?
Offer a very short reply. 5.11. What is the difference between the highest and the lowest Primary completion rate (% of total enrollments) of Europe(all income levels)?
Your answer should be compact. 0.68. What is the difference between the highest and the lowest Primary completion rate (% of total enrollments) in Gambia, The?
Provide a succinct answer. 20.35. What is the difference between the highest and the lowest Primary completion rate (% of total enrollments) of Sweden?
Offer a very short reply. 12.76. What is the difference between the highest and the lowest Primary completion rate (% of total enrollments) of Yemen, Rep.?
Offer a very short reply. 12.7. 